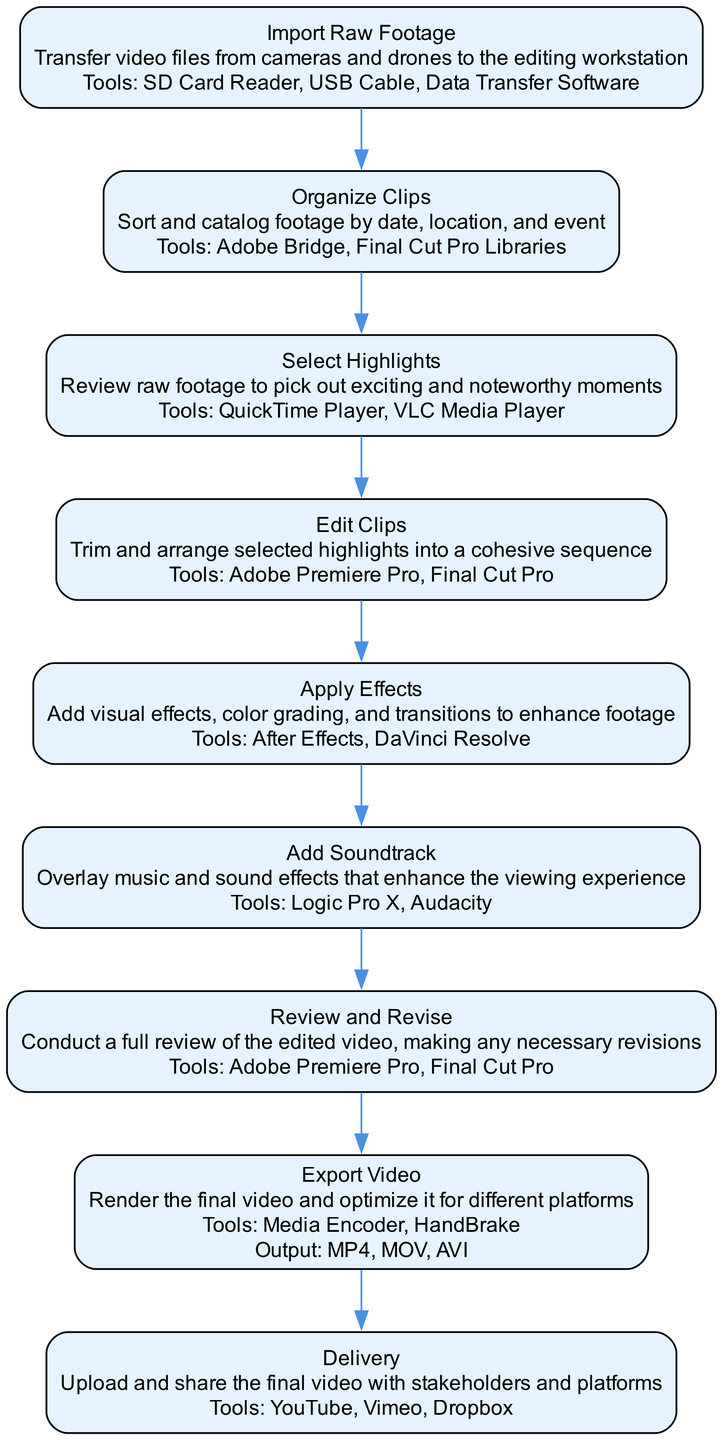What is the first step in the kite surfing video production workflow? The diagram starts with the step "Import Raw Footage," indicating that this is the first action in the process.
Answer: Import Raw Footage How many steps are there in the process? By counting each labeled step in the diagram, there are a total of 9 steps listed, from "Import Raw Footage" to "Delivery."
Answer: 9 What tools are used for editing the clips? The "Edit Clips" step specifies the tools: "Adobe Premiere Pro" and "Final Cut Pro." These are directly mentioned under that step in the diagram.
Answer: Adobe Premiere Pro, Final Cut Pro What is the output format specified for the exported video? The "Export Video" step clearly lists the output formats of "MP4," "MOV," and "AVI." These formats indicate how the video will be rendered at this stage.
Answer: MP4, MOV, AVI What is the last step in the workflow? The final step shown in the diagram is "Delivery," meaning that this is where the process concludes after all prior steps have been completed.
Answer: Delivery Which step comes immediately after "Select Highlights"? According to the order of the steps in the diagram, "Edit Clips" comes directly after "Select Highlights," creating a sequential process in the editing workflow.
Answer: Edit Clips What tools are suggested for adding soundtracks? In the "Add Soundtrack" step, the tools mentioned are "Logic Pro X" and "Audacity," indicating the software options for enhancing audio during editing.
Answer: Logic Pro X, Audacity How does the flow chart illustrate the relationship between selecting highlights and exporting the video? The flow chart shows a sequence where "Select Highlights" leads directly to "Edit Clips," which then progresses through several steps to finally reach "Export Video," demonstrating a clear, linear progression from one phase to the next in the editing process.
Answer: Linear progression from Select Highlights to Export Video What is the main purpose of the "Review and Revise" step? This step's purpose, as indicated in the diagram, is to conduct a full review of the edited video and make necessary revisions, ensuring the quality of the final product before delivery.
Answer: Conduct a full review and make revisions 